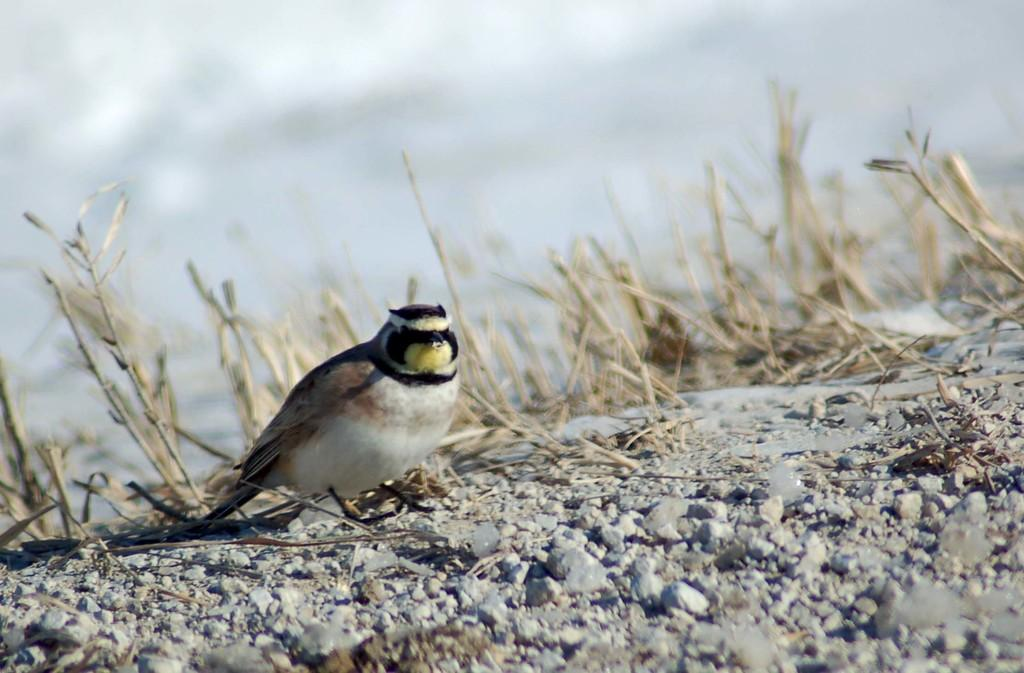What type of animal can be seen in the picture? There is a bird in the picture. Where is the bird located in the image? The bird is standing on the ground. What is the ground covered with in the image? The ground is covered with stones and dry grass. Can you see a needle on the ground in the image? There is no needle present on the ground in the image. 